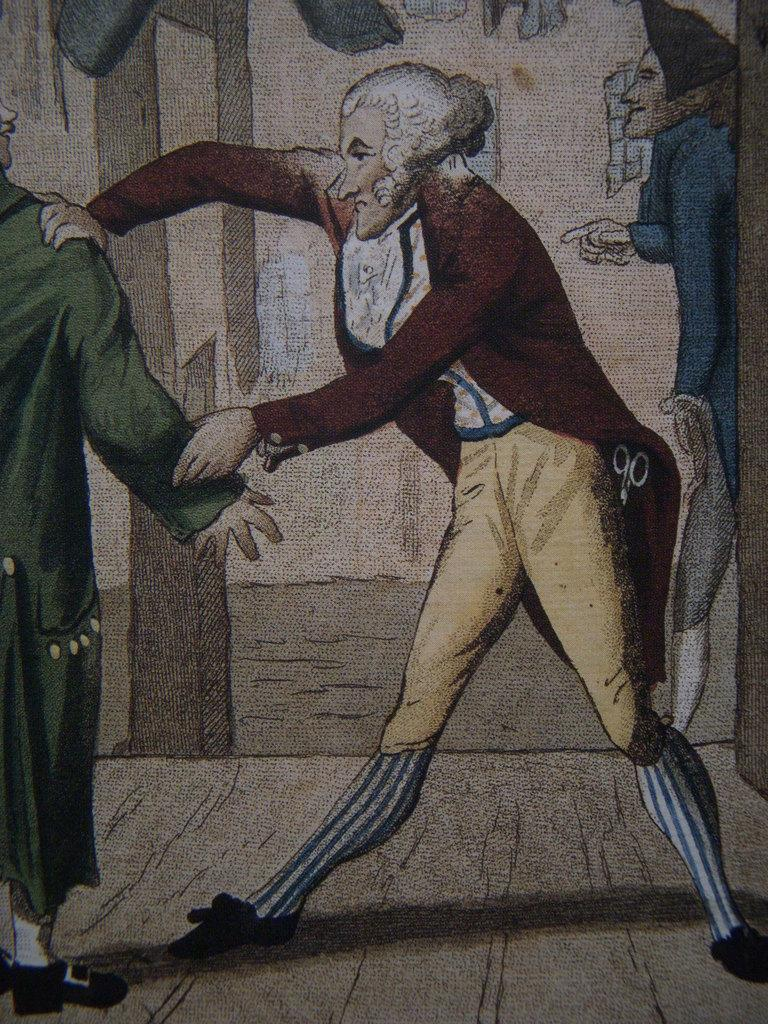What type of artwork is depicted in the image? The image is a painting. What can be seen on the floor in the painting? There are persons standing on the floor in the painting. What is visible in the background of the painting? There is a wall, windows, and a pillar in the background of the painting. How many chairs are present in the painting? There are no chairs visible in the painting. Can you describe the tramp in the painting? There is no tramp present in the painting. 